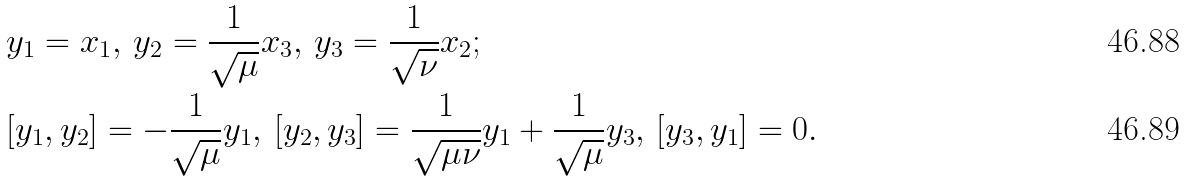Convert formula to latex. <formula><loc_0><loc_0><loc_500><loc_500>& y _ { 1 } = x _ { 1 } , \, y _ { 2 } = \frac { 1 } { \sqrt { \mu } } x _ { 3 } , \, y _ { 3 } = \frac { 1 } { \sqrt { \nu } } x _ { 2 } ; \\ & [ y _ { 1 } , y _ { 2 } ] = - \frac { 1 } { \sqrt { \mu } } y _ { 1 } , \, [ y _ { 2 } , y _ { 3 } ] = \frac { 1 } { \sqrt { \mu \nu } } y _ { 1 } + \frac { 1 } { \sqrt { \mu } } y _ { 3 } , \, [ y _ { 3 } , y _ { 1 } ] = 0 .</formula> 